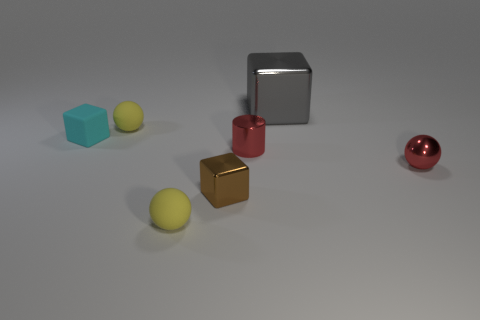What number of other objects are there of the same color as the big metal cube? There are no other objects of the same silver color as the big metal cube in the image. 